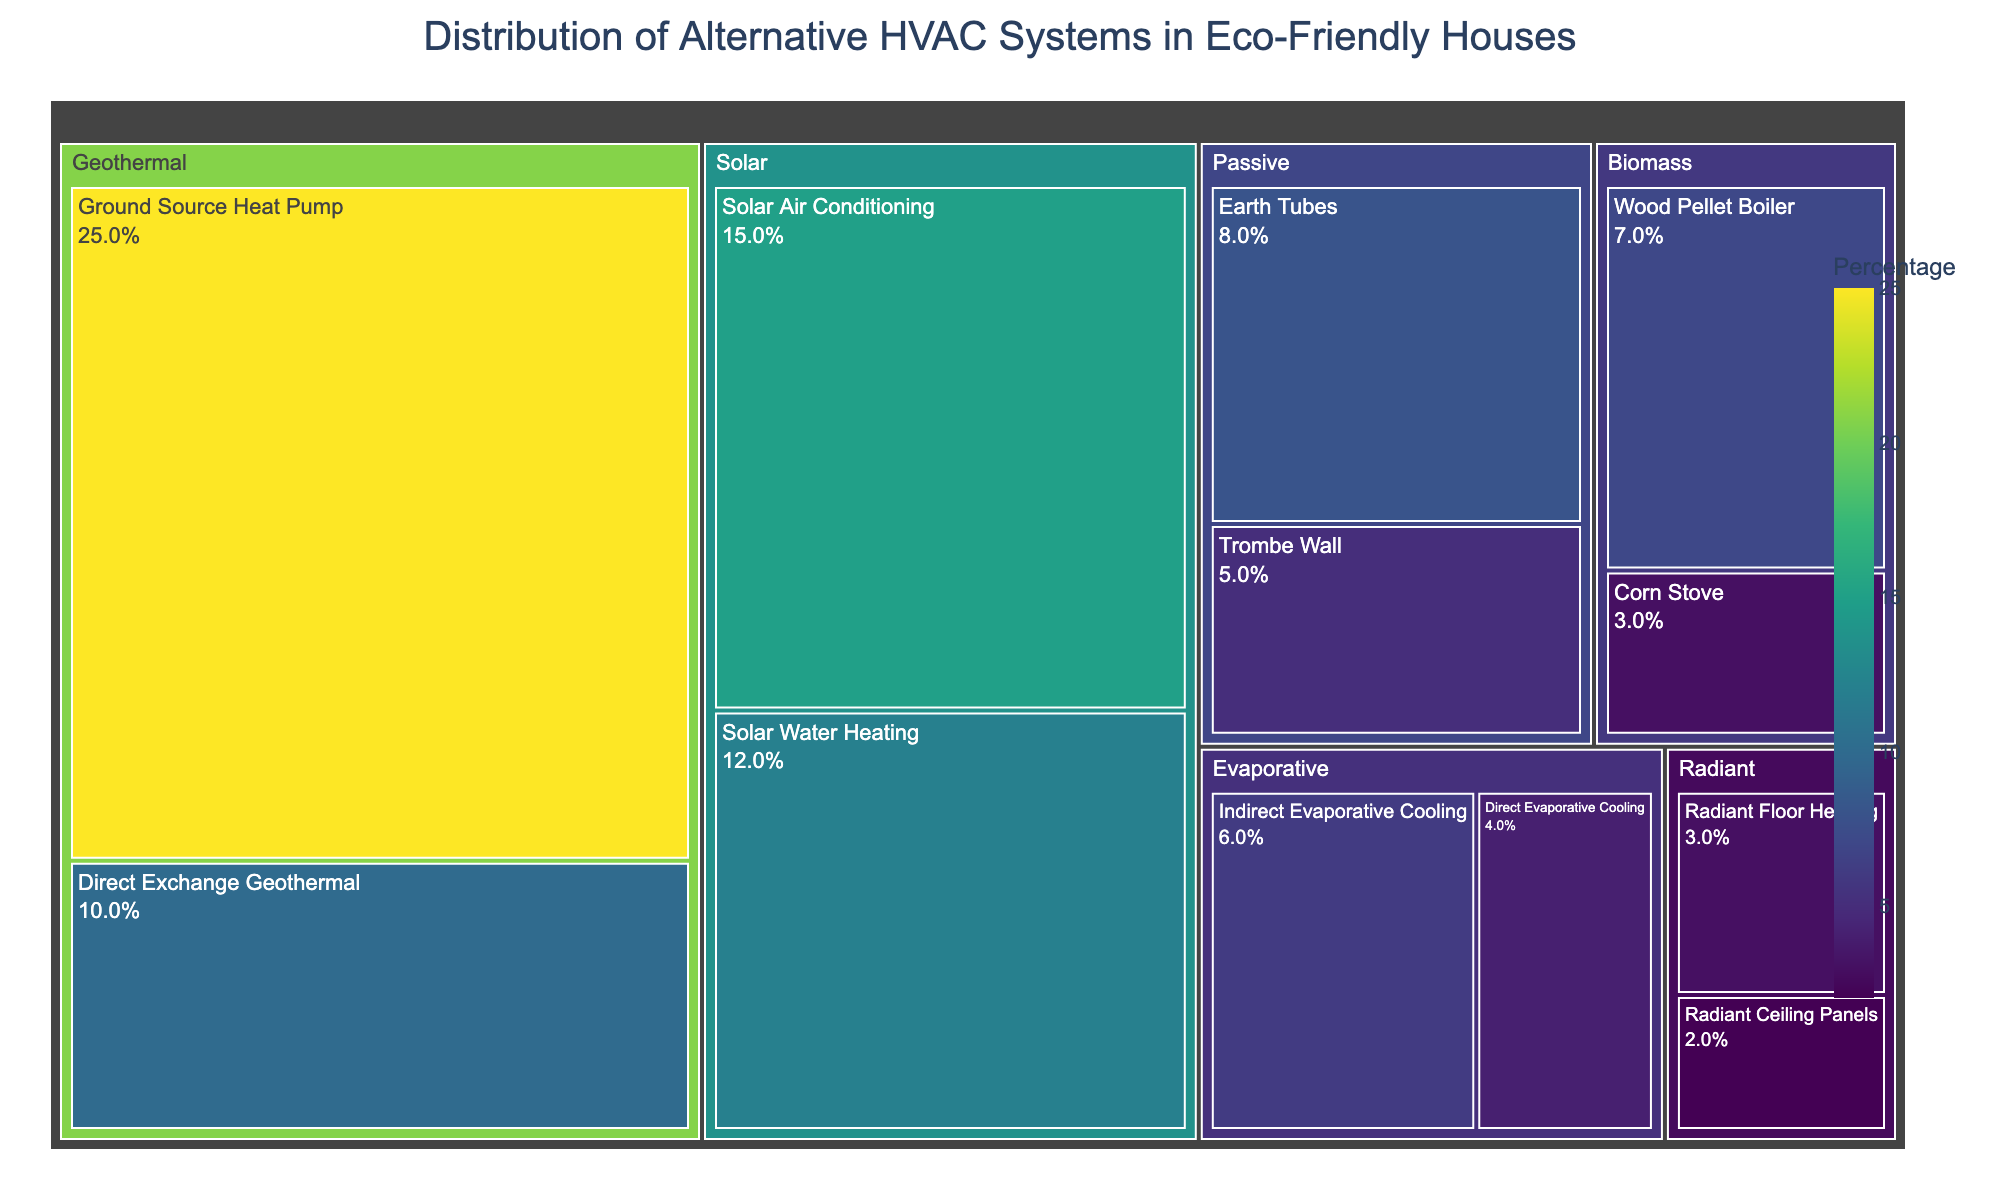What is the title of the figure? Look at the top of the plot where the title is usually located, above the visualization area.
Answer: Distribution of Alternative HVAC Systems in Eco-Friendly Houses Which category has the highest percentage for a single system? Identify the largest individual segment in the treemap, which is often the most prominent in size and color intensity.
Answer: Geothermal What is the sum of the percentages for the Solar and Evaporative categories? Identify and sum up the percentages for systems under the Solar (15+12) and Evaporative (6+4) categories.
Answer: 37% How does the percentage of Ground Source Heat Pump compare to Direct Exchange Geothermal? Locate both segments under the Geothermal category and compare their percentages.
Answer: Ground Source Heat Pump is 15% higher Which system has a larger percentage: Trombe Wall or Radiant Floor Heating? Identify and compare the percentages of Trombe Wall and Radiant Floor Heating segments in the treemap.
Answer: Trombe Wall What is the combined percentage of all biomass-based HVAC systems? Identify the Biomass category and sum the percentages of Wood Pellet Boiler (7) and Corn Stove (3).
Answer: 10% Which category has the smallest total percentage, and what are the combined percentages of its systems? Sum the percentages for each category and find the one with the smallest total, including its components.
Answer: Radiant (3+2) How much larger is the percentage of Earth Tubes compared to Radiant Ceiling Panels? Find and subtract the percentage of Radiant Ceiling Panels from that of Earth Tubes.
Answer: 6% larger What percentage of the total does the Solar Air Conditioning system represent? Identify the segment for Solar Air Conditioning and note its percentage.
Answer: 15% By how much does the percentage of Passive systems exceed that of the Biomass systems? Sum the percentages for Passive (8+5) and Biomass (7+3), then find the difference.
Answer: 3% 